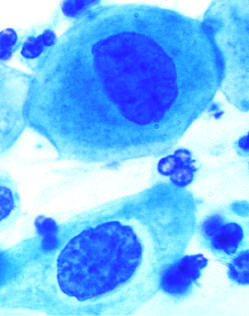what does this observation reflect?
Answer the question using a single word or phrase. The progressive loss of cellular differentiation on the surface of the cervical lesions from which these cells are exfoliated 